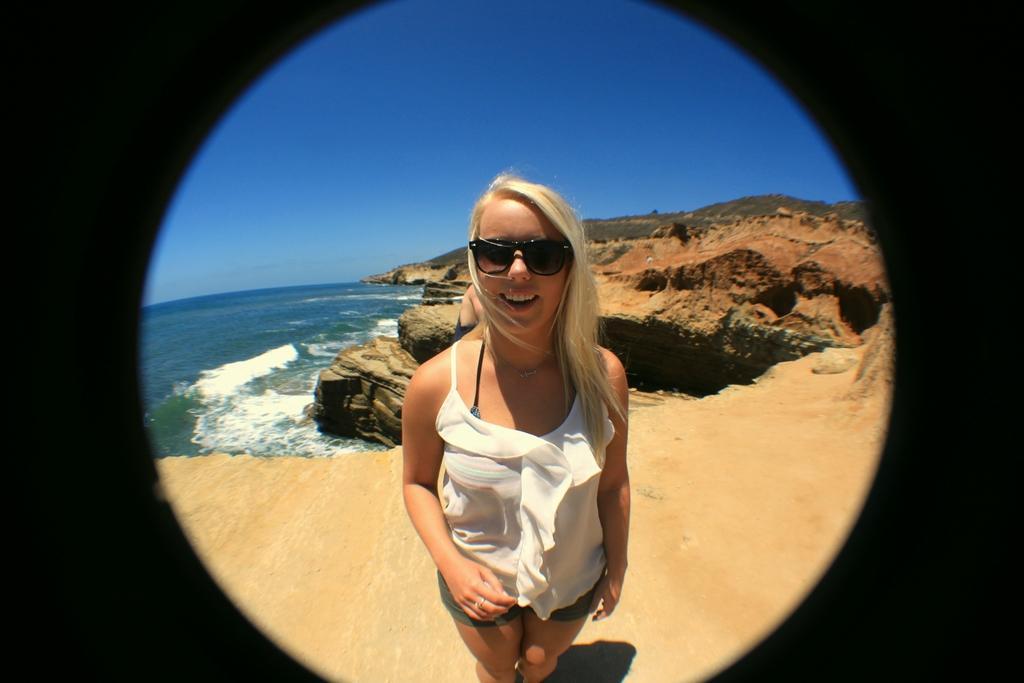How would you summarize this image in a sentence or two? In this image there is a girl standing on the sea shore behind her there is a big rock and beach. 